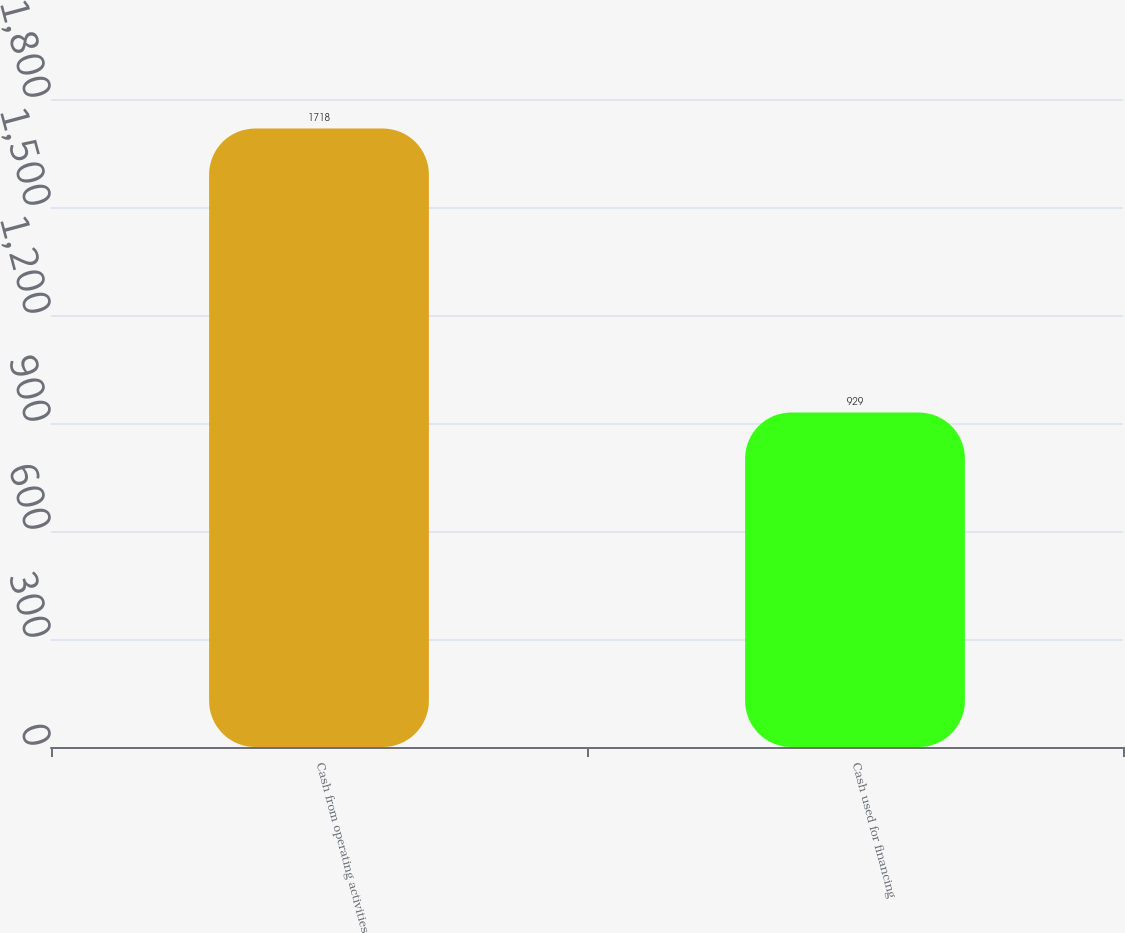Convert chart to OTSL. <chart><loc_0><loc_0><loc_500><loc_500><bar_chart><fcel>Cash from operating activities<fcel>Cash used for financing<nl><fcel>1718<fcel>929<nl></chart> 